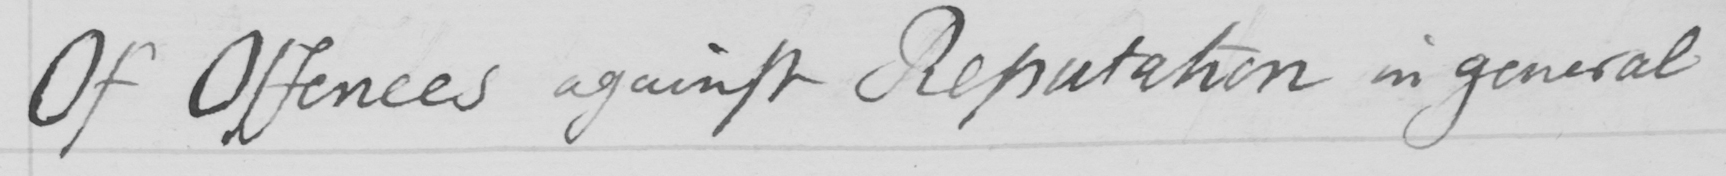Transcribe the text shown in this historical manuscript line. Of Offences against Reputation in general 